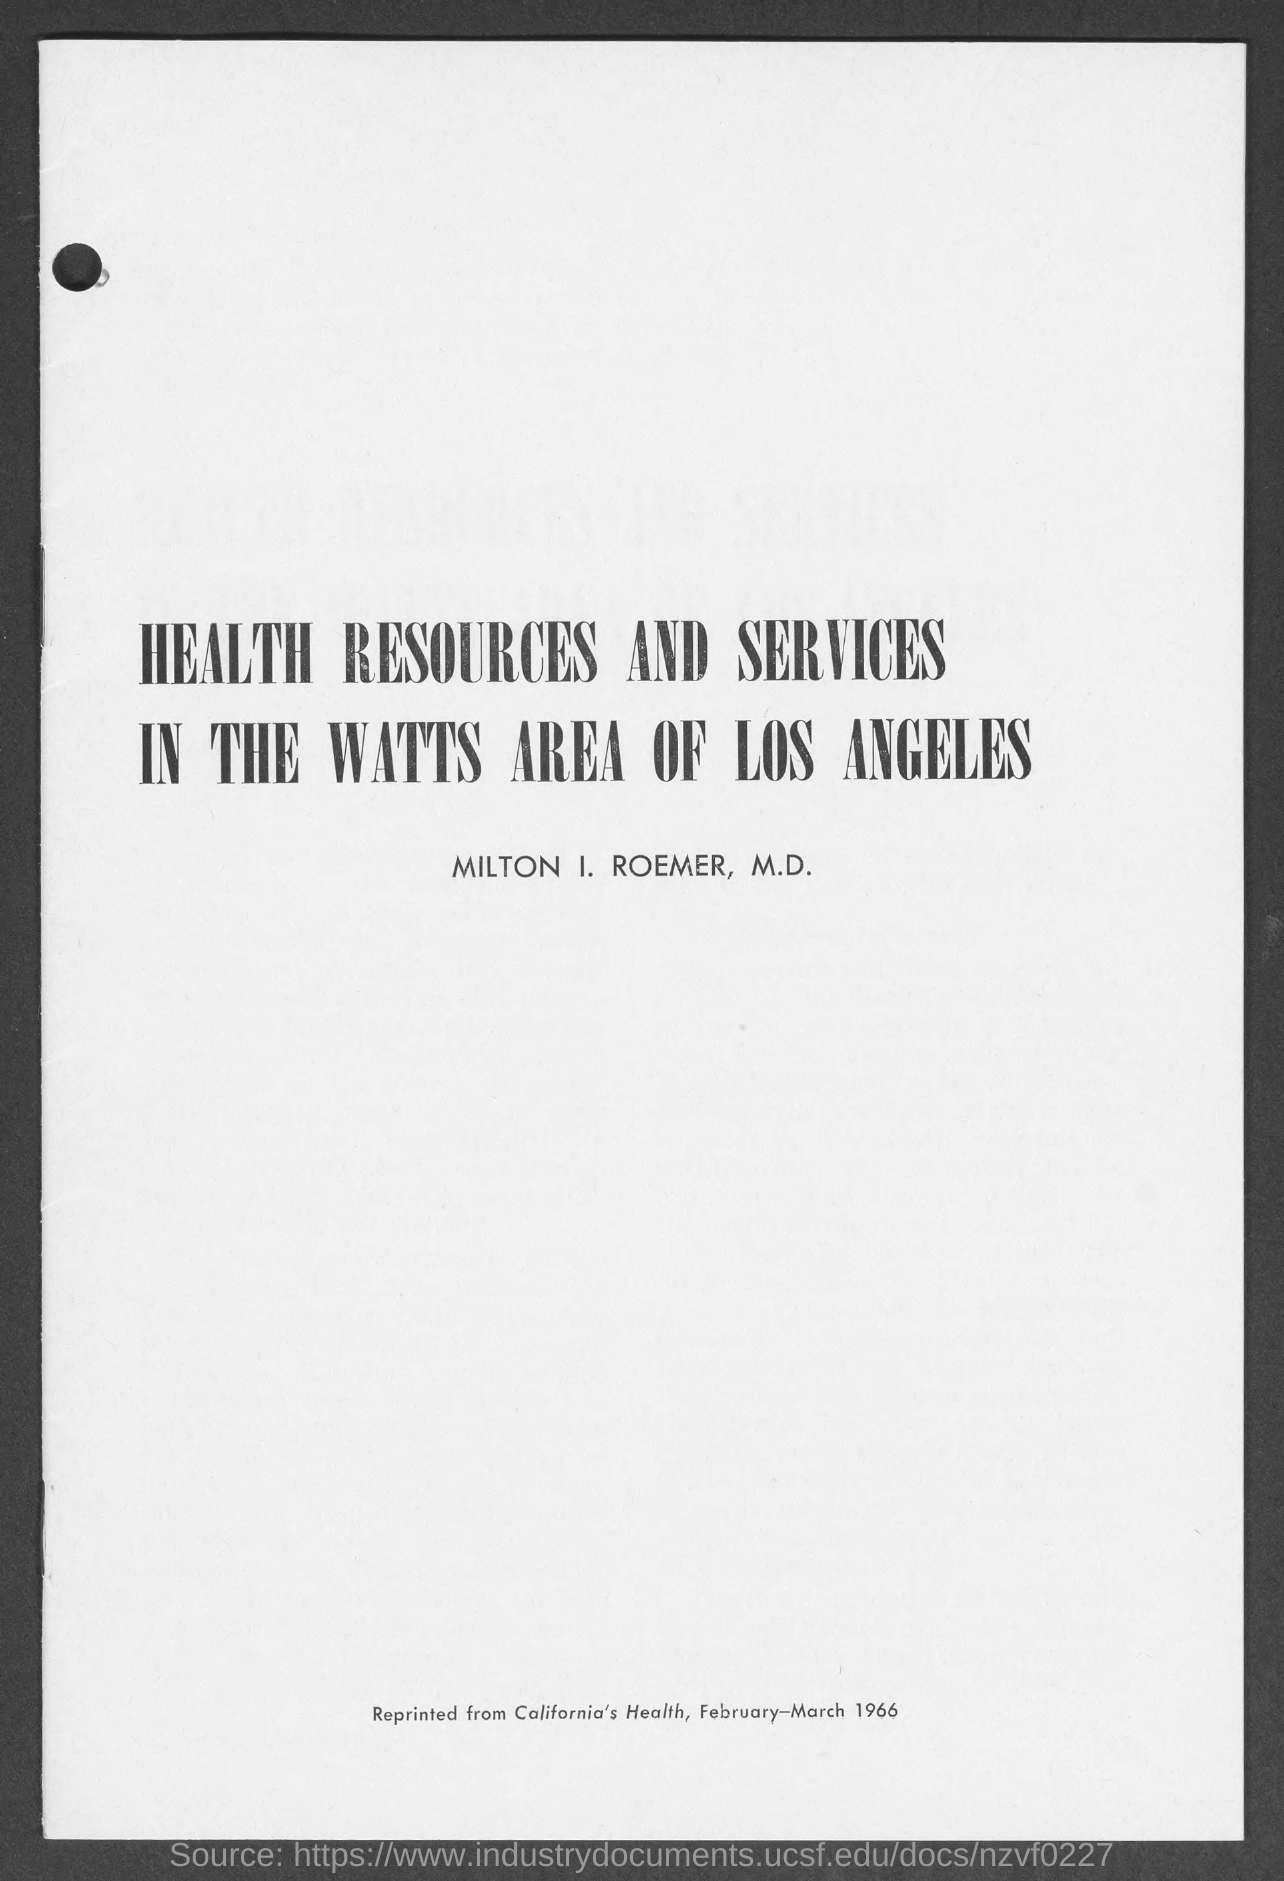Specify some key components in this picture. The document mentions a person named MILTON I. ROEMER, M.D. The document contains information regarding the date, which is February-March 1966. The document titled 'Health Resources and Services in the Watts Area of Los Angeles' is a declaration of the availability of health resources and services in the Watts area of Los Angeles. 